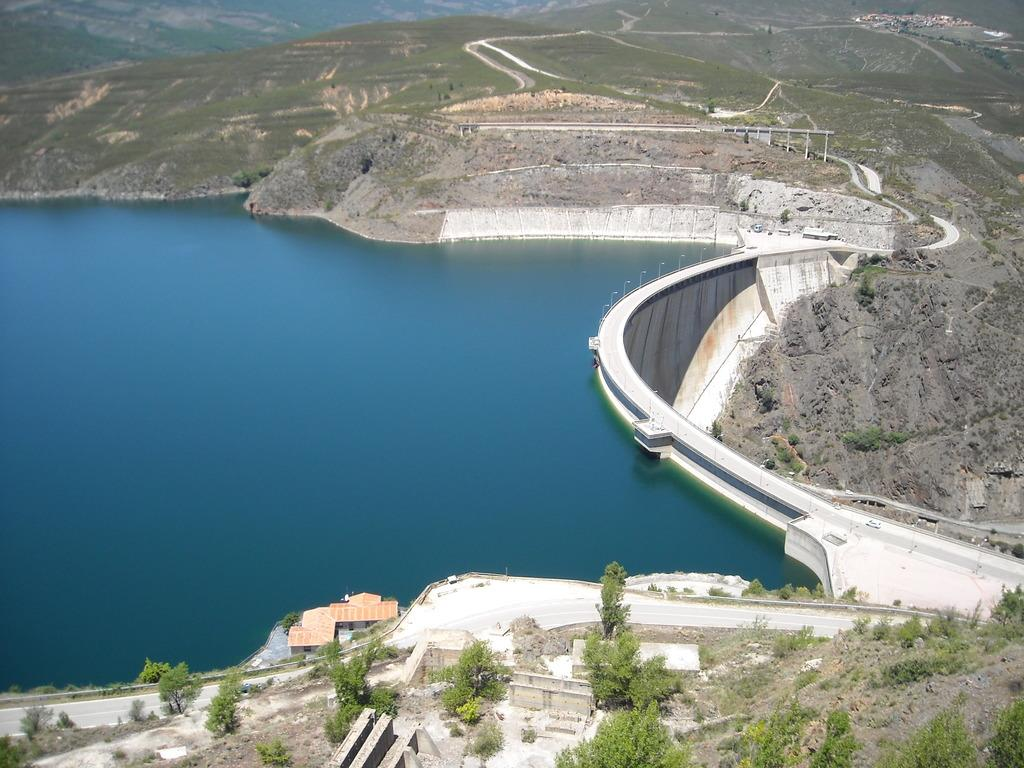What is the main feature of the landscape in the image? There is a road in the image. What can be seen near the road? There are many trees visible near the road. What type of structure is present in the image? There is a house in the image. What geographical features are visible in the background? There are mountains in the image. What is the color of the water visible in the image? The water is blue in color. Can you see any giants walking along the road in the image? There are no giants present in the image; it features a road, trees, a house, mountains, and blue water. 